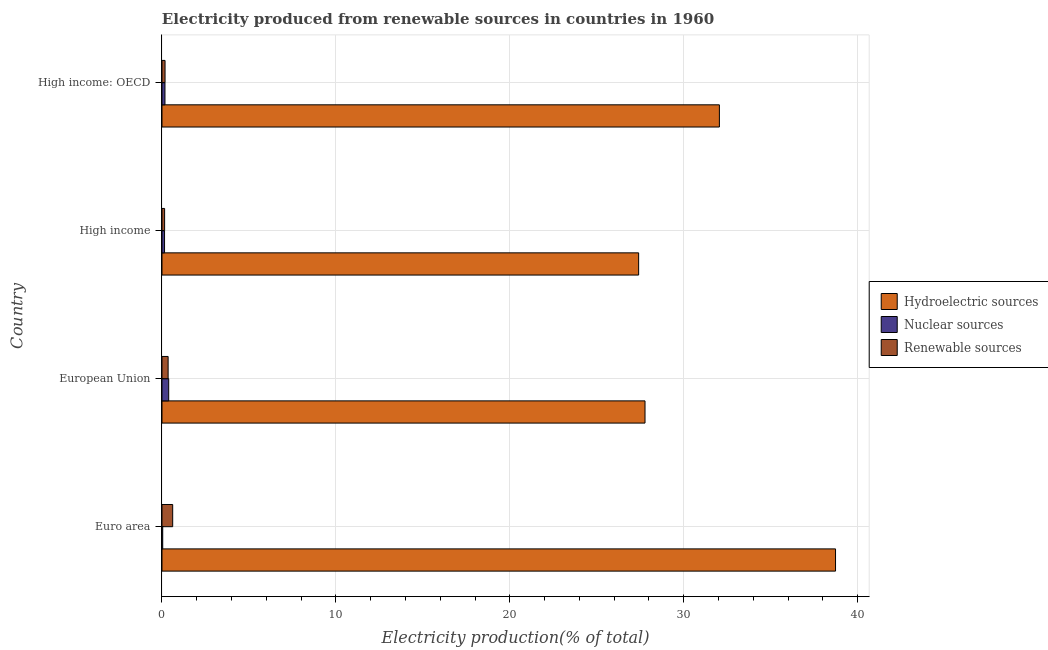How many different coloured bars are there?
Provide a short and direct response. 3. Are the number of bars per tick equal to the number of legend labels?
Your response must be concise. Yes. How many bars are there on the 1st tick from the top?
Provide a short and direct response. 3. How many bars are there on the 2nd tick from the bottom?
Provide a succinct answer. 3. What is the percentage of electricity produced by renewable sources in High income?
Offer a terse response. 0.15. Across all countries, what is the maximum percentage of electricity produced by nuclear sources?
Your answer should be compact. 0.39. Across all countries, what is the minimum percentage of electricity produced by renewable sources?
Make the answer very short. 0.15. In which country was the percentage of electricity produced by renewable sources minimum?
Keep it short and to the point. High income. What is the total percentage of electricity produced by hydroelectric sources in the graph?
Offer a terse response. 125.95. What is the difference between the percentage of electricity produced by hydroelectric sources in High income and that in High income: OECD?
Give a very brief answer. -4.64. What is the difference between the percentage of electricity produced by nuclear sources in High income and the percentage of electricity produced by hydroelectric sources in High income: OECD?
Your answer should be very brief. -31.9. What is the average percentage of electricity produced by nuclear sources per country?
Make the answer very short. 0.19. What is the difference between the percentage of electricity produced by hydroelectric sources and percentage of electricity produced by nuclear sources in European Union?
Your answer should be compact. 27.39. In how many countries, is the percentage of electricity produced by nuclear sources greater than 38 %?
Your answer should be very brief. 0. What is the ratio of the percentage of electricity produced by nuclear sources in Euro area to that in High income: OECD?
Your answer should be very brief. 0.24. Is the percentage of electricity produced by renewable sources in Euro area less than that in High income: OECD?
Offer a very short reply. No. Is the difference between the percentage of electricity produced by nuclear sources in European Union and High income: OECD greater than the difference between the percentage of electricity produced by renewable sources in European Union and High income: OECD?
Provide a succinct answer. Yes. What is the difference between the highest and the second highest percentage of electricity produced by hydroelectric sources?
Make the answer very short. 6.68. What is the difference between the highest and the lowest percentage of electricity produced by hydroelectric sources?
Provide a succinct answer. 11.32. Is the sum of the percentage of electricity produced by nuclear sources in High income and High income: OECD greater than the maximum percentage of electricity produced by hydroelectric sources across all countries?
Make the answer very short. No. What does the 3rd bar from the top in Euro area represents?
Ensure brevity in your answer.  Hydroelectric sources. What does the 2nd bar from the bottom in European Union represents?
Your answer should be very brief. Nuclear sources. Are all the bars in the graph horizontal?
Give a very brief answer. Yes. Does the graph contain grids?
Your answer should be compact. Yes. How many legend labels are there?
Keep it short and to the point. 3. What is the title of the graph?
Give a very brief answer. Electricity produced from renewable sources in countries in 1960. Does "Secondary" appear as one of the legend labels in the graph?
Offer a terse response. No. What is the label or title of the X-axis?
Offer a very short reply. Electricity production(% of total). What is the label or title of the Y-axis?
Make the answer very short. Country. What is the Electricity production(% of total) of Hydroelectric sources in Euro area?
Ensure brevity in your answer.  38.73. What is the Electricity production(% of total) in Nuclear sources in Euro area?
Offer a very short reply. 0.04. What is the Electricity production(% of total) in Renewable sources in Euro area?
Offer a terse response. 0.62. What is the Electricity production(% of total) in Hydroelectric sources in European Union?
Ensure brevity in your answer.  27.77. What is the Electricity production(% of total) of Nuclear sources in European Union?
Your answer should be very brief. 0.39. What is the Electricity production(% of total) of Renewable sources in European Union?
Make the answer very short. 0.35. What is the Electricity production(% of total) of Hydroelectric sources in High income?
Your answer should be very brief. 27.41. What is the Electricity production(% of total) of Nuclear sources in High income?
Your response must be concise. 0.15. What is the Electricity production(% of total) in Renewable sources in High income?
Offer a terse response. 0.15. What is the Electricity production(% of total) in Hydroelectric sources in High income: OECD?
Provide a short and direct response. 32.05. What is the Electricity production(% of total) of Nuclear sources in High income: OECD?
Your answer should be very brief. 0.17. What is the Electricity production(% of total) of Renewable sources in High income: OECD?
Provide a short and direct response. 0.18. Across all countries, what is the maximum Electricity production(% of total) of Hydroelectric sources?
Your response must be concise. 38.73. Across all countries, what is the maximum Electricity production(% of total) of Nuclear sources?
Offer a very short reply. 0.39. Across all countries, what is the maximum Electricity production(% of total) of Renewable sources?
Offer a terse response. 0.62. Across all countries, what is the minimum Electricity production(% of total) of Hydroelectric sources?
Make the answer very short. 27.41. Across all countries, what is the minimum Electricity production(% of total) in Nuclear sources?
Your answer should be very brief. 0.04. Across all countries, what is the minimum Electricity production(% of total) of Renewable sources?
Offer a very short reply. 0.15. What is the total Electricity production(% of total) in Hydroelectric sources in the graph?
Your response must be concise. 125.95. What is the total Electricity production(% of total) in Nuclear sources in the graph?
Offer a very short reply. 0.75. What is the total Electricity production(% of total) in Renewable sources in the graph?
Make the answer very short. 1.3. What is the difference between the Electricity production(% of total) of Hydroelectric sources in Euro area and that in European Union?
Your answer should be compact. 10.95. What is the difference between the Electricity production(% of total) of Nuclear sources in Euro area and that in European Union?
Offer a terse response. -0.34. What is the difference between the Electricity production(% of total) in Renewable sources in Euro area and that in European Union?
Provide a succinct answer. 0.26. What is the difference between the Electricity production(% of total) in Hydroelectric sources in Euro area and that in High income?
Your answer should be very brief. 11.32. What is the difference between the Electricity production(% of total) in Nuclear sources in Euro area and that in High income?
Make the answer very short. -0.11. What is the difference between the Electricity production(% of total) of Renewable sources in Euro area and that in High income?
Your response must be concise. 0.46. What is the difference between the Electricity production(% of total) in Hydroelectric sources in Euro area and that in High income: OECD?
Provide a short and direct response. 6.68. What is the difference between the Electricity production(% of total) in Nuclear sources in Euro area and that in High income: OECD?
Offer a very short reply. -0.13. What is the difference between the Electricity production(% of total) in Renewable sources in Euro area and that in High income: OECD?
Provide a succinct answer. 0.44. What is the difference between the Electricity production(% of total) in Hydroelectric sources in European Union and that in High income?
Your answer should be compact. 0.37. What is the difference between the Electricity production(% of total) of Nuclear sources in European Union and that in High income?
Ensure brevity in your answer.  0.24. What is the difference between the Electricity production(% of total) in Renewable sources in European Union and that in High income?
Your answer should be compact. 0.2. What is the difference between the Electricity production(% of total) of Hydroelectric sources in European Union and that in High income: OECD?
Make the answer very short. -4.28. What is the difference between the Electricity production(% of total) in Nuclear sources in European Union and that in High income: OECD?
Provide a short and direct response. 0.21. What is the difference between the Electricity production(% of total) in Renewable sources in European Union and that in High income: OECD?
Give a very brief answer. 0.18. What is the difference between the Electricity production(% of total) in Hydroelectric sources in High income and that in High income: OECD?
Provide a short and direct response. -4.64. What is the difference between the Electricity production(% of total) in Nuclear sources in High income and that in High income: OECD?
Provide a short and direct response. -0.02. What is the difference between the Electricity production(% of total) of Renewable sources in High income and that in High income: OECD?
Ensure brevity in your answer.  -0.03. What is the difference between the Electricity production(% of total) of Hydroelectric sources in Euro area and the Electricity production(% of total) of Nuclear sources in European Union?
Your answer should be compact. 38.34. What is the difference between the Electricity production(% of total) of Hydroelectric sources in Euro area and the Electricity production(% of total) of Renewable sources in European Union?
Your answer should be very brief. 38.37. What is the difference between the Electricity production(% of total) of Nuclear sources in Euro area and the Electricity production(% of total) of Renewable sources in European Union?
Provide a succinct answer. -0.31. What is the difference between the Electricity production(% of total) in Hydroelectric sources in Euro area and the Electricity production(% of total) in Nuclear sources in High income?
Keep it short and to the point. 38.58. What is the difference between the Electricity production(% of total) of Hydroelectric sources in Euro area and the Electricity production(% of total) of Renewable sources in High income?
Give a very brief answer. 38.57. What is the difference between the Electricity production(% of total) of Nuclear sources in Euro area and the Electricity production(% of total) of Renewable sources in High income?
Ensure brevity in your answer.  -0.11. What is the difference between the Electricity production(% of total) of Hydroelectric sources in Euro area and the Electricity production(% of total) of Nuclear sources in High income: OECD?
Your response must be concise. 38.55. What is the difference between the Electricity production(% of total) in Hydroelectric sources in Euro area and the Electricity production(% of total) in Renewable sources in High income: OECD?
Offer a very short reply. 38.55. What is the difference between the Electricity production(% of total) in Nuclear sources in Euro area and the Electricity production(% of total) in Renewable sources in High income: OECD?
Ensure brevity in your answer.  -0.13. What is the difference between the Electricity production(% of total) in Hydroelectric sources in European Union and the Electricity production(% of total) in Nuclear sources in High income?
Your response must be concise. 27.62. What is the difference between the Electricity production(% of total) of Hydroelectric sources in European Union and the Electricity production(% of total) of Renewable sources in High income?
Offer a terse response. 27.62. What is the difference between the Electricity production(% of total) in Nuclear sources in European Union and the Electricity production(% of total) in Renewable sources in High income?
Keep it short and to the point. 0.24. What is the difference between the Electricity production(% of total) in Hydroelectric sources in European Union and the Electricity production(% of total) in Nuclear sources in High income: OECD?
Your answer should be very brief. 27.6. What is the difference between the Electricity production(% of total) in Hydroelectric sources in European Union and the Electricity production(% of total) in Renewable sources in High income: OECD?
Ensure brevity in your answer.  27.6. What is the difference between the Electricity production(% of total) in Nuclear sources in European Union and the Electricity production(% of total) in Renewable sources in High income: OECD?
Offer a terse response. 0.21. What is the difference between the Electricity production(% of total) of Hydroelectric sources in High income and the Electricity production(% of total) of Nuclear sources in High income: OECD?
Provide a short and direct response. 27.23. What is the difference between the Electricity production(% of total) of Hydroelectric sources in High income and the Electricity production(% of total) of Renewable sources in High income: OECD?
Ensure brevity in your answer.  27.23. What is the difference between the Electricity production(% of total) of Nuclear sources in High income and the Electricity production(% of total) of Renewable sources in High income: OECD?
Provide a succinct answer. -0.03. What is the average Electricity production(% of total) of Hydroelectric sources per country?
Ensure brevity in your answer.  31.49. What is the average Electricity production(% of total) in Nuclear sources per country?
Provide a succinct answer. 0.19. What is the average Electricity production(% of total) in Renewable sources per country?
Ensure brevity in your answer.  0.32. What is the difference between the Electricity production(% of total) in Hydroelectric sources and Electricity production(% of total) in Nuclear sources in Euro area?
Give a very brief answer. 38.68. What is the difference between the Electricity production(% of total) of Hydroelectric sources and Electricity production(% of total) of Renewable sources in Euro area?
Offer a terse response. 38.11. What is the difference between the Electricity production(% of total) in Nuclear sources and Electricity production(% of total) in Renewable sources in Euro area?
Offer a terse response. -0.57. What is the difference between the Electricity production(% of total) of Hydroelectric sources and Electricity production(% of total) of Nuclear sources in European Union?
Ensure brevity in your answer.  27.39. What is the difference between the Electricity production(% of total) in Hydroelectric sources and Electricity production(% of total) in Renewable sources in European Union?
Your answer should be very brief. 27.42. What is the difference between the Electricity production(% of total) of Nuclear sources and Electricity production(% of total) of Renewable sources in European Union?
Your response must be concise. 0.03. What is the difference between the Electricity production(% of total) of Hydroelectric sources and Electricity production(% of total) of Nuclear sources in High income?
Your answer should be very brief. 27.26. What is the difference between the Electricity production(% of total) of Hydroelectric sources and Electricity production(% of total) of Renewable sources in High income?
Provide a short and direct response. 27.25. What is the difference between the Electricity production(% of total) in Nuclear sources and Electricity production(% of total) in Renewable sources in High income?
Your response must be concise. -0. What is the difference between the Electricity production(% of total) in Hydroelectric sources and Electricity production(% of total) in Nuclear sources in High income: OECD?
Offer a very short reply. 31.88. What is the difference between the Electricity production(% of total) of Hydroelectric sources and Electricity production(% of total) of Renewable sources in High income: OECD?
Provide a short and direct response. 31.87. What is the difference between the Electricity production(% of total) in Nuclear sources and Electricity production(% of total) in Renewable sources in High income: OECD?
Keep it short and to the point. -0. What is the ratio of the Electricity production(% of total) in Hydroelectric sources in Euro area to that in European Union?
Offer a very short reply. 1.39. What is the ratio of the Electricity production(% of total) of Nuclear sources in Euro area to that in European Union?
Offer a terse response. 0.11. What is the ratio of the Electricity production(% of total) in Renewable sources in Euro area to that in European Union?
Give a very brief answer. 1.74. What is the ratio of the Electricity production(% of total) in Hydroelectric sources in Euro area to that in High income?
Make the answer very short. 1.41. What is the ratio of the Electricity production(% of total) of Nuclear sources in Euro area to that in High income?
Provide a short and direct response. 0.28. What is the ratio of the Electricity production(% of total) of Renewable sources in Euro area to that in High income?
Your answer should be compact. 4.08. What is the ratio of the Electricity production(% of total) of Hydroelectric sources in Euro area to that in High income: OECD?
Give a very brief answer. 1.21. What is the ratio of the Electricity production(% of total) of Nuclear sources in Euro area to that in High income: OECD?
Your answer should be very brief. 0.24. What is the ratio of the Electricity production(% of total) of Renewable sources in Euro area to that in High income: OECD?
Provide a short and direct response. 3.49. What is the ratio of the Electricity production(% of total) in Hydroelectric sources in European Union to that in High income?
Provide a short and direct response. 1.01. What is the ratio of the Electricity production(% of total) of Nuclear sources in European Union to that in High income?
Make the answer very short. 2.63. What is the ratio of the Electricity production(% of total) of Renewable sources in European Union to that in High income?
Your response must be concise. 2.34. What is the ratio of the Electricity production(% of total) in Hydroelectric sources in European Union to that in High income: OECD?
Your answer should be very brief. 0.87. What is the ratio of the Electricity production(% of total) in Nuclear sources in European Union to that in High income: OECD?
Offer a terse response. 2.24. What is the ratio of the Electricity production(% of total) in Renewable sources in European Union to that in High income: OECD?
Provide a short and direct response. 2. What is the ratio of the Electricity production(% of total) of Hydroelectric sources in High income to that in High income: OECD?
Keep it short and to the point. 0.86. What is the ratio of the Electricity production(% of total) in Nuclear sources in High income to that in High income: OECD?
Provide a short and direct response. 0.86. What is the ratio of the Electricity production(% of total) in Renewable sources in High income to that in High income: OECD?
Your response must be concise. 0.86. What is the difference between the highest and the second highest Electricity production(% of total) in Hydroelectric sources?
Your response must be concise. 6.68. What is the difference between the highest and the second highest Electricity production(% of total) in Nuclear sources?
Ensure brevity in your answer.  0.21. What is the difference between the highest and the second highest Electricity production(% of total) of Renewable sources?
Your answer should be very brief. 0.26. What is the difference between the highest and the lowest Electricity production(% of total) of Hydroelectric sources?
Provide a succinct answer. 11.32. What is the difference between the highest and the lowest Electricity production(% of total) in Nuclear sources?
Provide a succinct answer. 0.34. What is the difference between the highest and the lowest Electricity production(% of total) of Renewable sources?
Make the answer very short. 0.46. 